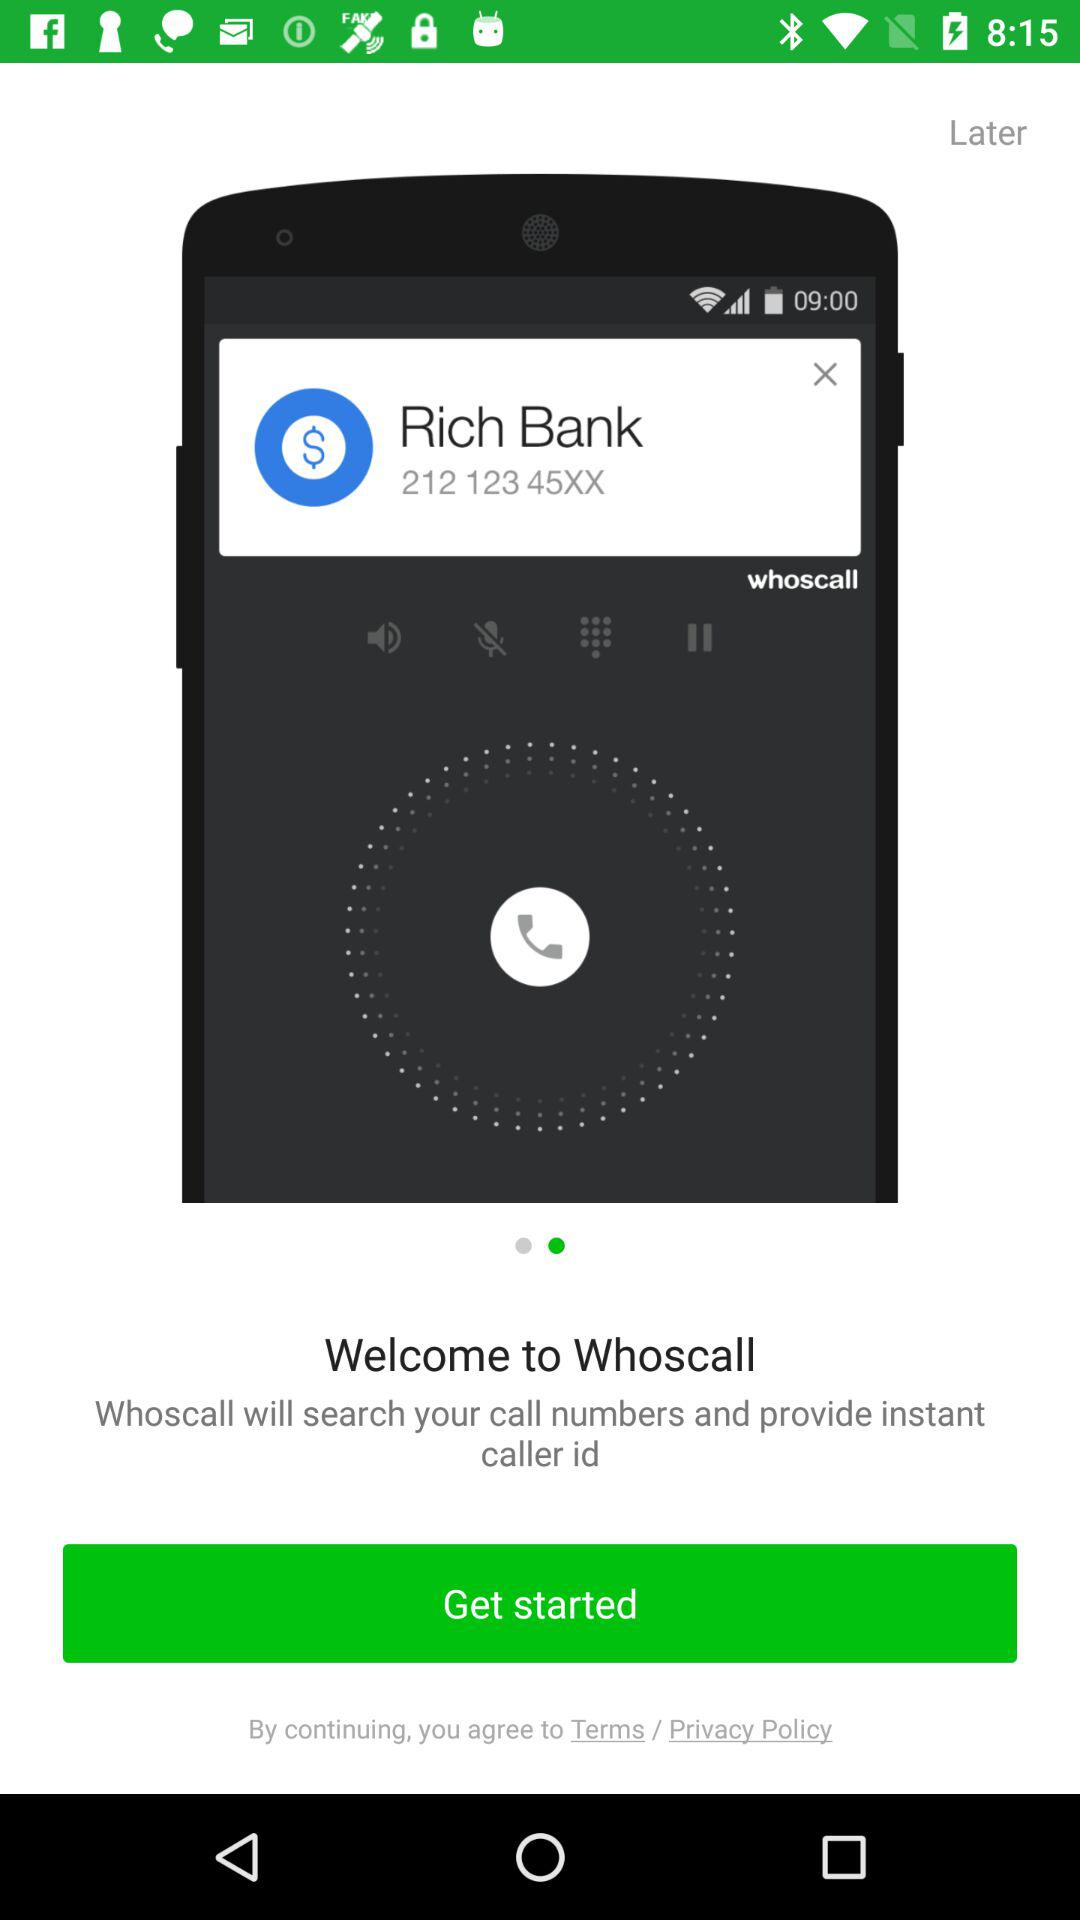What is the contact number for "Rich Bank"? The contact number is 212 123 45XX. 